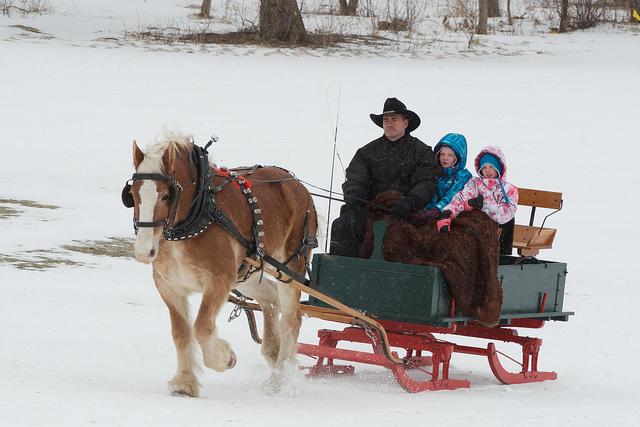Does that man look like Garth Brooks?
Short answer required. Yes. What are the people riding in?
Answer briefly. Sleigh. How many people is in the sled?
Short answer required. 3. What covers the ground?
Be succinct. Snow. 